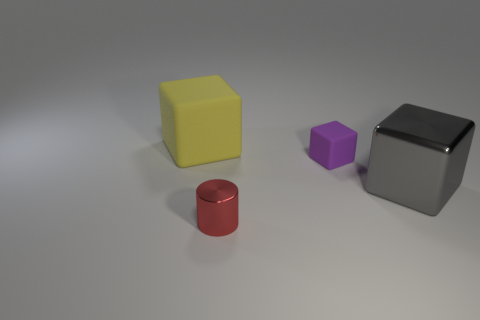Subtract all gray blocks. How many blocks are left? 2 Subtract all blocks. How many objects are left? 1 Subtract 2 blocks. How many blocks are left? 1 Subtract all yellow cylinders. Subtract all yellow blocks. How many cylinders are left? 1 Subtract all green cylinders. How many yellow cubes are left? 1 Subtract all small red objects. Subtract all tiny purple rubber blocks. How many objects are left? 2 Add 3 large gray shiny blocks. How many large gray shiny blocks are left? 4 Add 2 green cylinders. How many green cylinders exist? 2 Add 4 yellow blocks. How many objects exist? 8 Subtract all gray cubes. How many cubes are left? 2 